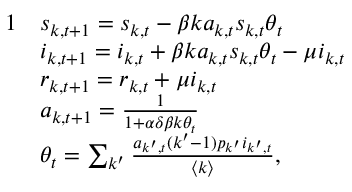Convert formula to latex. <formula><loc_0><loc_0><loc_500><loc_500>\begin{array} { r l } { 1 } & { s _ { k , t + 1 } = s _ { k , t } - \beta k a _ { k , t } s _ { k , t } \theta _ { t } } \\ & { i _ { k , t + 1 } = i _ { k , t } + \beta k a _ { k , t } s _ { k , t } \theta _ { t } - \mu i _ { k , t } } \\ & { r _ { k , t + 1 } = r _ { k , t } + \mu i _ { k , t } } \\ & { a _ { k , t + 1 } = \frac { 1 } { 1 + \alpha \delta \beta k \theta _ { t } } } \\ & { \theta _ { t } = \sum _ { k ^ { \prime } } \frac { a _ { k ^ { \prime } , t } ( k ^ { \prime } - 1 ) p _ { k ^ { \prime } } i _ { k ^ { \prime } , t } } { \langle k \rangle } , } \end{array}</formula> 